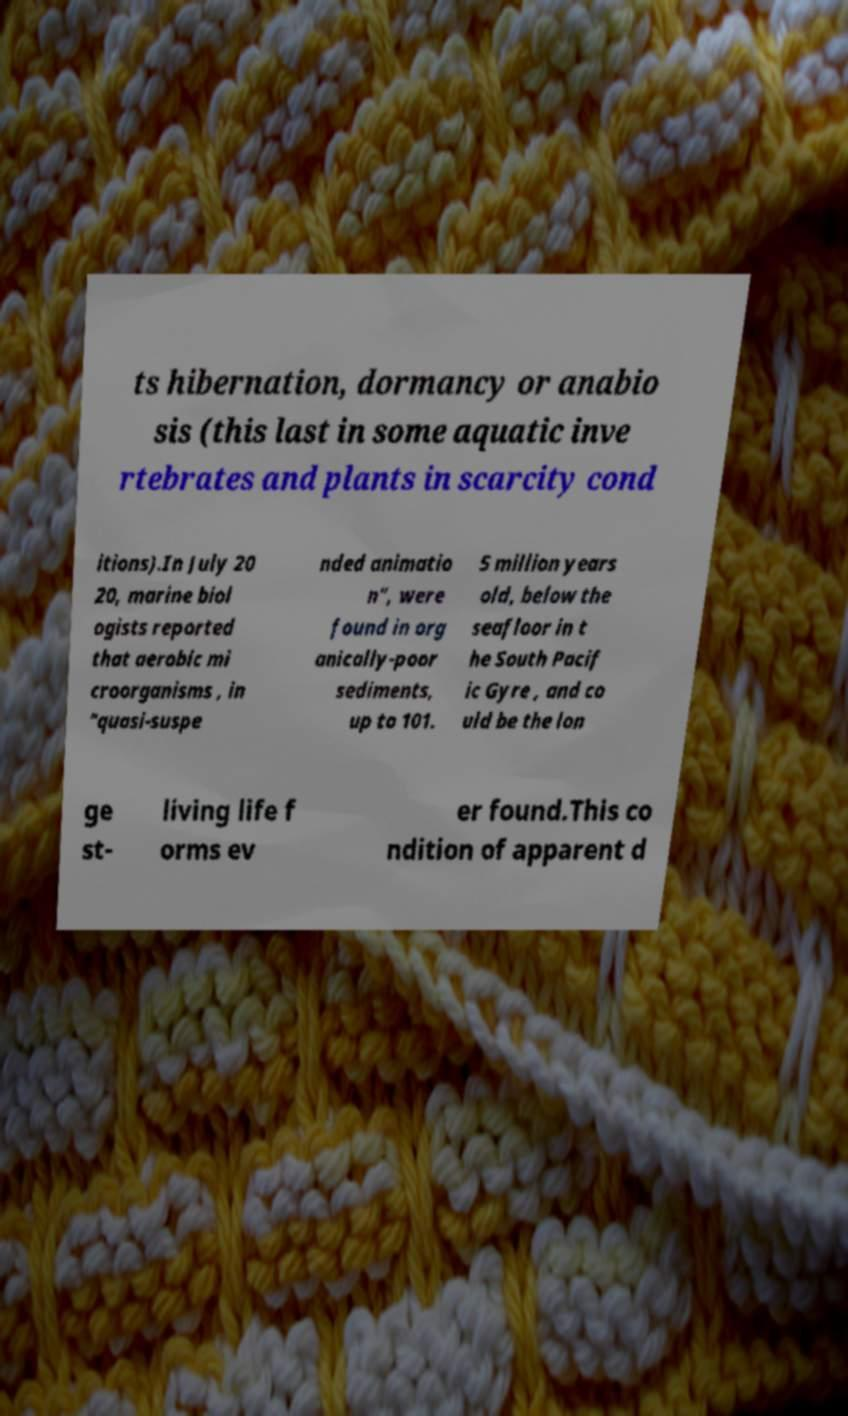There's text embedded in this image that I need extracted. Can you transcribe it verbatim? ts hibernation, dormancy or anabio sis (this last in some aquatic inve rtebrates and plants in scarcity cond itions).In July 20 20, marine biol ogists reported that aerobic mi croorganisms , in "quasi-suspe nded animatio n", were found in org anically-poor sediments, up to 101. 5 million years old, below the seafloor in t he South Pacif ic Gyre , and co uld be the lon ge st- living life f orms ev er found.This co ndition of apparent d 